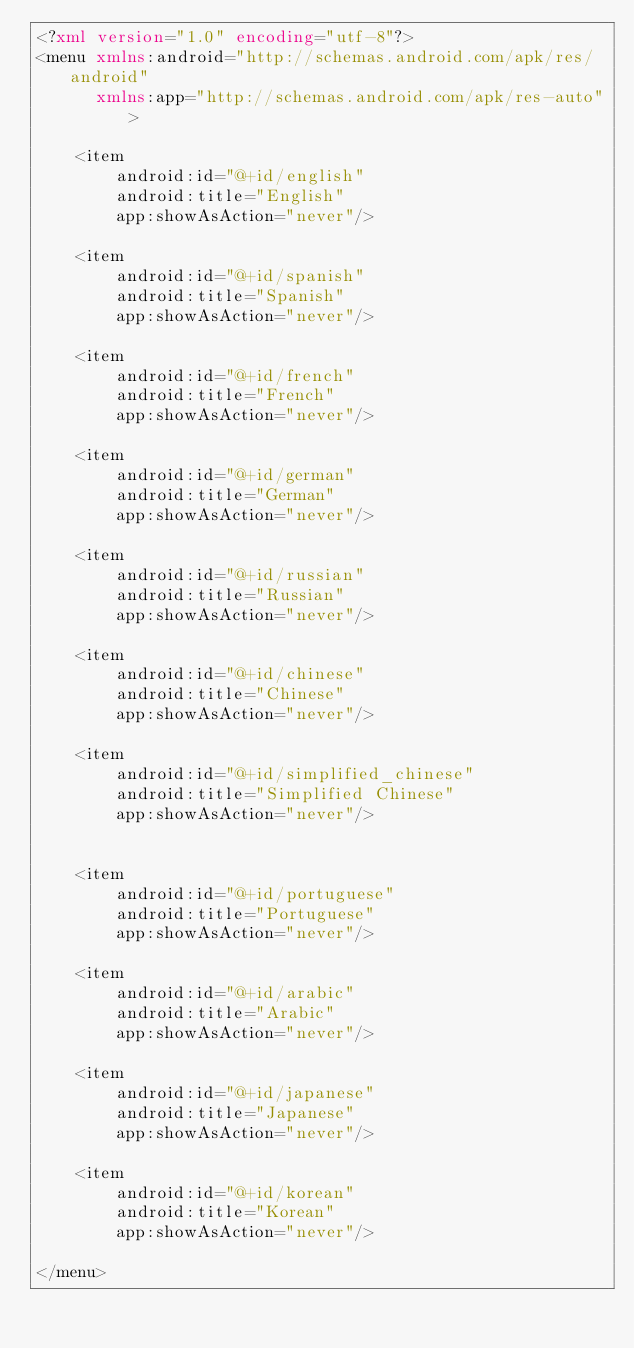Convert code to text. <code><loc_0><loc_0><loc_500><loc_500><_XML_><?xml version="1.0" encoding="utf-8"?>
<menu xmlns:android="http://schemas.android.com/apk/res/android"
      xmlns:app="http://schemas.android.com/apk/res-auto">

    <item
        android:id="@+id/english"
        android:title="English"
        app:showAsAction="never"/>

    <item
        android:id="@+id/spanish"
        android:title="Spanish"
        app:showAsAction="never"/>

    <item
        android:id="@+id/french"
        android:title="French"
        app:showAsAction="never"/>

    <item
        android:id="@+id/german"
        android:title="German"
        app:showAsAction="never"/>

    <item
        android:id="@+id/russian"
        android:title="Russian"
        app:showAsAction="never"/>

    <item
        android:id="@+id/chinese"
        android:title="Chinese"
        app:showAsAction="never"/>

    <item
        android:id="@+id/simplified_chinese"
        android:title="Simplified Chinese"
        app:showAsAction="never"/>


    <item
        android:id="@+id/portuguese"
        android:title="Portuguese"
        app:showAsAction="never"/>

    <item
        android:id="@+id/arabic"
        android:title="Arabic"
        app:showAsAction="never"/>

    <item
        android:id="@+id/japanese"
        android:title="Japanese"
        app:showAsAction="never"/>

    <item
        android:id="@+id/korean"
        android:title="Korean"
        app:showAsAction="never"/>

</menu></code> 